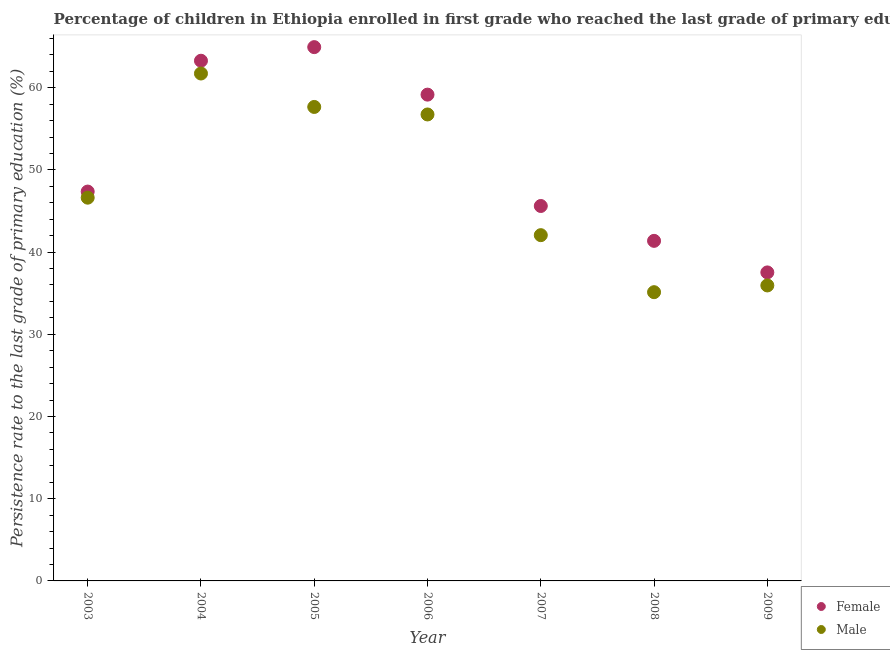What is the persistence rate of male students in 2008?
Offer a terse response. 35.12. Across all years, what is the maximum persistence rate of male students?
Your answer should be compact. 61.72. Across all years, what is the minimum persistence rate of female students?
Ensure brevity in your answer.  37.53. In which year was the persistence rate of male students maximum?
Your answer should be compact. 2004. What is the total persistence rate of female students in the graph?
Provide a succinct answer. 359.24. What is the difference between the persistence rate of female students in 2003 and that in 2006?
Provide a succinct answer. -11.79. What is the difference between the persistence rate of female students in 2006 and the persistence rate of male students in 2004?
Ensure brevity in your answer.  -2.57. What is the average persistence rate of female students per year?
Make the answer very short. 51.32. In the year 2009, what is the difference between the persistence rate of female students and persistence rate of male students?
Give a very brief answer. 1.59. In how many years, is the persistence rate of male students greater than 46 %?
Your answer should be very brief. 4. What is the ratio of the persistence rate of male students in 2005 to that in 2007?
Give a very brief answer. 1.37. Is the difference between the persistence rate of female students in 2005 and 2006 greater than the difference between the persistence rate of male students in 2005 and 2006?
Keep it short and to the point. Yes. What is the difference between the highest and the second highest persistence rate of male students?
Provide a short and direct response. 4.07. What is the difference between the highest and the lowest persistence rate of male students?
Make the answer very short. 26.6. Is the sum of the persistence rate of female students in 2005 and 2006 greater than the maximum persistence rate of male students across all years?
Your answer should be compact. Yes. Is the persistence rate of female students strictly greater than the persistence rate of male students over the years?
Your answer should be very brief. Yes. Are the values on the major ticks of Y-axis written in scientific E-notation?
Keep it short and to the point. No. Does the graph contain any zero values?
Provide a short and direct response. No. Where does the legend appear in the graph?
Your answer should be compact. Bottom right. How many legend labels are there?
Your response must be concise. 2. How are the legend labels stacked?
Provide a short and direct response. Vertical. What is the title of the graph?
Keep it short and to the point. Percentage of children in Ethiopia enrolled in first grade who reached the last grade of primary education. Does "Food and tobacco" appear as one of the legend labels in the graph?
Keep it short and to the point. No. What is the label or title of the X-axis?
Make the answer very short. Year. What is the label or title of the Y-axis?
Ensure brevity in your answer.  Persistence rate to the last grade of primary education (%). What is the Persistence rate to the last grade of primary education (%) of Female in 2003?
Provide a succinct answer. 47.36. What is the Persistence rate to the last grade of primary education (%) of Male in 2003?
Provide a short and direct response. 46.62. What is the Persistence rate to the last grade of primary education (%) of Female in 2004?
Make the answer very short. 63.28. What is the Persistence rate to the last grade of primary education (%) of Male in 2004?
Keep it short and to the point. 61.72. What is the Persistence rate to the last grade of primary education (%) in Female in 2005?
Give a very brief answer. 64.93. What is the Persistence rate to the last grade of primary education (%) of Male in 2005?
Your response must be concise. 57.66. What is the Persistence rate to the last grade of primary education (%) of Female in 2006?
Keep it short and to the point. 59.16. What is the Persistence rate to the last grade of primary education (%) of Male in 2006?
Your response must be concise. 56.74. What is the Persistence rate to the last grade of primary education (%) in Female in 2007?
Offer a very short reply. 45.61. What is the Persistence rate to the last grade of primary education (%) in Male in 2007?
Your answer should be compact. 42.06. What is the Persistence rate to the last grade of primary education (%) in Female in 2008?
Keep it short and to the point. 41.37. What is the Persistence rate to the last grade of primary education (%) of Male in 2008?
Make the answer very short. 35.12. What is the Persistence rate to the last grade of primary education (%) in Female in 2009?
Offer a very short reply. 37.53. What is the Persistence rate to the last grade of primary education (%) of Male in 2009?
Ensure brevity in your answer.  35.94. Across all years, what is the maximum Persistence rate to the last grade of primary education (%) of Female?
Provide a succinct answer. 64.93. Across all years, what is the maximum Persistence rate to the last grade of primary education (%) of Male?
Provide a succinct answer. 61.72. Across all years, what is the minimum Persistence rate to the last grade of primary education (%) in Female?
Your answer should be compact. 37.53. Across all years, what is the minimum Persistence rate to the last grade of primary education (%) in Male?
Ensure brevity in your answer.  35.12. What is the total Persistence rate to the last grade of primary education (%) of Female in the graph?
Your response must be concise. 359.24. What is the total Persistence rate to the last grade of primary education (%) of Male in the graph?
Ensure brevity in your answer.  335.88. What is the difference between the Persistence rate to the last grade of primary education (%) of Female in 2003 and that in 2004?
Your response must be concise. -15.91. What is the difference between the Persistence rate to the last grade of primary education (%) in Male in 2003 and that in 2004?
Your answer should be compact. -15.1. What is the difference between the Persistence rate to the last grade of primary education (%) in Female in 2003 and that in 2005?
Your answer should be compact. -17.57. What is the difference between the Persistence rate to the last grade of primary education (%) of Male in 2003 and that in 2005?
Your answer should be compact. -11.04. What is the difference between the Persistence rate to the last grade of primary education (%) of Female in 2003 and that in 2006?
Keep it short and to the point. -11.79. What is the difference between the Persistence rate to the last grade of primary education (%) in Male in 2003 and that in 2006?
Offer a very short reply. -10.12. What is the difference between the Persistence rate to the last grade of primary education (%) in Female in 2003 and that in 2007?
Your answer should be compact. 1.76. What is the difference between the Persistence rate to the last grade of primary education (%) of Male in 2003 and that in 2007?
Provide a short and direct response. 4.56. What is the difference between the Persistence rate to the last grade of primary education (%) in Female in 2003 and that in 2008?
Ensure brevity in your answer.  6. What is the difference between the Persistence rate to the last grade of primary education (%) of Male in 2003 and that in 2008?
Your response must be concise. 11.5. What is the difference between the Persistence rate to the last grade of primary education (%) of Female in 2003 and that in 2009?
Provide a short and direct response. 9.84. What is the difference between the Persistence rate to the last grade of primary education (%) in Male in 2003 and that in 2009?
Your answer should be compact. 10.68. What is the difference between the Persistence rate to the last grade of primary education (%) in Female in 2004 and that in 2005?
Your response must be concise. -1.66. What is the difference between the Persistence rate to the last grade of primary education (%) of Male in 2004 and that in 2005?
Your answer should be very brief. 4.07. What is the difference between the Persistence rate to the last grade of primary education (%) of Female in 2004 and that in 2006?
Provide a short and direct response. 4.12. What is the difference between the Persistence rate to the last grade of primary education (%) of Male in 2004 and that in 2006?
Make the answer very short. 4.98. What is the difference between the Persistence rate to the last grade of primary education (%) in Female in 2004 and that in 2007?
Your response must be concise. 17.67. What is the difference between the Persistence rate to the last grade of primary education (%) in Male in 2004 and that in 2007?
Offer a very short reply. 19.66. What is the difference between the Persistence rate to the last grade of primary education (%) of Female in 2004 and that in 2008?
Your answer should be compact. 21.91. What is the difference between the Persistence rate to the last grade of primary education (%) in Male in 2004 and that in 2008?
Offer a terse response. 26.6. What is the difference between the Persistence rate to the last grade of primary education (%) of Female in 2004 and that in 2009?
Ensure brevity in your answer.  25.75. What is the difference between the Persistence rate to the last grade of primary education (%) of Male in 2004 and that in 2009?
Provide a short and direct response. 25.78. What is the difference between the Persistence rate to the last grade of primary education (%) in Female in 2005 and that in 2006?
Give a very brief answer. 5.78. What is the difference between the Persistence rate to the last grade of primary education (%) of Male in 2005 and that in 2006?
Ensure brevity in your answer.  0.91. What is the difference between the Persistence rate to the last grade of primary education (%) of Female in 2005 and that in 2007?
Your answer should be compact. 19.33. What is the difference between the Persistence rate to the last grade of primary education (%) in Male in 2005 and that in 2007?
Provide a short and direct response. 15.6. What is the difference between the Persistence rate to the last grade of primary education (%) in Female in 2005 and that in 2008?
Your answer should be compact. 23.57. What is the difference between the Persistence rate to the last grade of primary education (%) in Male in 2005 and that in 2008?
Provide a succinct answer. 22.53. What is the difference between the Persistence rate to the last grade of primary education (%) in Female in 2005 and that in 2009?
Offer a terse response. 27.41. What is the difference between the Persistence rate to the last grade of primary education (%) of Male in 2005 and that in 2009?
Provide a succinct answer. 21.71. What is the difference between the Persistence rate to the last grade of primary education (%) in Female in 2006 and that in 2007?
Give a very brief answer. 13.55. What is the difference between the Persistence rate to the last grade of primary education (%) of Male in 2006 and that in 2007?
Make the answer very short. 14.68. What is the difference between the Persistence rate to the last grade of primary education (%) of Female in 2006 and that in 2008?
Ensure brevity in your answer.  17.79. What is the difference between the Persistence rate to the last grade of primary education (%) of Male in 2006 and that in 2008?
Provide a succinct answer. 21.62. What is the difference between the Persistence rate to the last grade of primary education (%) of Female in 2006 and that in 2009?
Make the answer very short. 21.63. What is the difference between the Persistence rate to the last grade of primary education (%) in Male in 2006 and that in 2009?
Your answer should be compact. 20.8. What is the difference between the Persistence rate to the last grade of primary education (%) in Female in 2007 and that in 2008?
Give a very brief answer. 4.24. What is the difference between the Persistence rate to the last grade of primary education (%) of Male in 2007 and that in 2008?
Offer a terse response. 6.94. What is the difference between the Persistence rate to the last grade of primary education (%) in Female in 2007 and that in 2009?
Your response must be concise. 8.08. What is the difference between the Persistence rate to the last grade of primary education (%) of Male in 2007 and that in 2009?
Make the answer very short. 6.12. What is the difference between the Persistence rate to the last grade of primary education (%) of Female in 2008 and that in 2009?
Offer a terse response. 3.84. What is the difference between the Persistence rate to the last grade of primary education (%) in Male in 2008 and that in 2009?
Your answer should be very brief. -0.82. What is the difference between the Persistence rate to the last grade of primary education (%) of Female in 2003 and the Persistence rate to the last grade of primary education (%) of Male in 2004?
Ensure brevity in your answer.  -14.36. What is the difference between the Persistence rate to the last grade of primary education (%) in Female in 2003 and the Persistence rate to the last grade of primary education (%) in Male in 2005?
Your answer should be very brief. -10.29. What is the difference between the Persistence rate to the last grade of primary education (%) in Female in 2003 and the Persistence rate to the last grade of primary education (%) in Male in 2006?
Provide a short and direct response. -9.38. What is the difference between the Persistence rate to the last grade of primary education (%) of Female in 2003 and the Persistence rate to the last grade of primary education (%) of Male in 2007?
Your answer should be very brief. 5.3. What is the difference between the Persistence rate to the last grade of primary education (%) of Female in 2003 and the Persistence rate to the last grade of primary education (%) of Male in 2008?
Provide a short and direct response. 12.24. What is the difference between the Persistence rate to the last grade of primary education (%) of Female in 2003 and the Persistence rate to the last grade of primary education (%) of Male in 2009?
Provide a succinct answer. 11.42. What is the difference between the Persistence rate to the last grade of primary education (%) of Female in 2004 and the Persistence rate to the last grade of primary education (%) of Male in 2005?
Give a very brief answer. 5.62. What is the difference between the Persistence rate to the last grade of primary education (%) in Female in 2004 and the Persistence rate to the last grade of primary education (%) in Male in 2006?
Provide a short and direct response. 6.54. What is the difference between the Persistence rate to the last grade of primary education (%) in Female in 2004 and the Persistence rate to the last grade of primary education (%) in Male in 2007?
Offer a terse response. 21.22. What is the difference between the Persistence rate to the last grade of primary education (%) in Female in 2004 and the Persistence rate to the last grade of primary education (%) in Male in 2008?
Make the answer very short. 28.15. What is the difference between the Persistence rate to the last grade of primary education (%) in Female in 2004 and the Persistence rate to the last grade of primary education (%) in Male in 2009?
Provide a succinct answer. 27.34. What is the difference between the Persistence rate to the last grade of primary education (%) in Female in 2005 and the Persistence rate to the last grade of primary education (%) in Male in 2006?
Your answer should be very brief. 8.19. What is the difference between the Persistence rate to the last grade of primary education (%) of Female in 2005 and the Persistence rate to the last grade of primary education (%) of Male in 2007?
Your answer should be very brief. 22.87. What is the difference between the Persistence rate to the last grade of primary education (%) in Female in 2005 and the Persistence rate to the last grade of primary education (%) in Male in 2008?
Your response must be concise. 29.81. What is the difference between the Persistence rate to the last grade of primary education (%) of Female in 2005 and the Persistence rate to the last grade of primary education (%) of Male in 2009?
Your answer should be compact. 28.99. What is the difference between the Persistence rate to the last grade of primary education (%) in Female in 2006 and the Persistence rate to the last grade of primary education (%) in Male in 2007?
Give a very brief answer. 17.1. What is the difference between the Persistence rate to the last grade of primary education (%) in Female in 2006 and the Persistence rate to the last grade of primary education (%) in Male in 2008?
Provide a short and direct response. 24.03. What is the difference between the Persistence rate to the last grade of primary education (%) of Female in 2006 and the Persistence rate to the last grade of primary education (%) of Male in 2009?
Offer a terse response. 23.21. What is the difference between the Persistence rate to the last grade of primary education (%) in Female in 2007 and the Persistence rate to the last grade of primary education (%) in Male in 2008?
Your answer should be very brief. 10.48. What is the difference between the Persistence rate to the last grade of primary education (%) of Female in 2007 and the Persistence rate to the last grade of primary education (%) of Male in 2009?
Your answer should be very brief. 9.67. What is the difference between the Persistence rate to the last grade of primary education (%) of Female in 2008 and the Persistence rate to the last grade of primary education (%) of Male in 2009?
Offer a terse response. 5.42. What is the average Persistence rate to the last grade of primary education (%) in Female per year?
Make the answer very short. 51.32. What is the average Persistence rate to the last grade of primary education (%) in Male per year?
Your answer should be very brief. 47.98. In the year 2003, what is the difference between the Persistence rate to the last grade of primary education (%) in Female and Persistence rate to the last grade of primary education (%) in Male?
Your response must be concise. 0.74. In the year 2004, what is the difference between the Persistence rate to the last grade of primary education (%) of Female and Persistence rate to the last grade of primary education (%) of Male?
Offer a terse response. 1.55. In the year 2005, what is the difference between the Persistence rate to the last grade of primary education (%) of Female and Persistence rate to the last grade of primary education (%) of Male?
Ensure brevity in your answer.  7.28. In the year 2006, what is the difference between the Persistence rate to the last grade of primary education (%) of Female and Persistence rate to the last grade of primary education (%) of Male?
Offer a terse response. 2.41. In the year 2007, what is the difference between the Persistence rate to the last grade of primary education (%) of Female and Persistence rate to the last grade of primary education (%) of Male?
Provide a short and direct response. 3.55. In the year 2008, what is the difference between the Persistence rate to the last grade of primary education (%) of Female and Persistence rate to the last grade of primary education (%) of Male?
Give a very brief answer. 6.24. In the year 2009, what is the difference between the Persistence rate to the last grade of primary education (%) in Female and Persistence rate to the last grade of primary education (%) in Male?
Your response must be concise. 1.59. What is the ratio of the Persistence rate to the last grade of primary education (%) in Female in 2003 to that in 2004?
Provide a succinct answer. 0.75. What is the ratio of the Persistence rate to the last grade of primary education (%) of Male in 2003 to that in 2004?
Your answer should be compact. 0.76. What is the ratio of the Persistence rate to the last grade of primary education (%) of Female in 2003 to that in 2005?
Make the answer very short. 0.73. What is the ratio of the Persistence rate to the last grade of primary education (%) in Male in 2003 to that in 2005?
Make the answer very short. 0.81. What is the ratio of the Persistence rate to the last grade of primary education (%) in Female in 2003 to that in 2006?
Give a very brief answer. 0.8. What is the ratio of the Persistence rate to the last grade of primary education (%) of Male in 2003 to that in 2006?
Your response must be concise. 0.82. What is the ratio of the Persistence rate to the last grade of primary education (%) of Female in 2003 to that in 2007?
Your answer should be compact. 1.04. What is the ratio of the Persistence rate to the last grade of primary education (%) of Male in 2003 to that in 2007?
Ensure brevity in your answer.  1.11. What is the ratio of the Persistence rate to the last grade of primary education (%) in Female in 2003 to that in 2008?
Make the answer very short. 1.14. What is the ratio of the Persistence rate to the last grade of primary education (%) of Male in 2003 to that in 2008?
Ensure brevity in your answer.  1.33. What is the ratio of the Persistence rate to the last grade of primary education (%) in Female in 2003 to that in 2009?
Offer a terse response. 1.26. What is the ratio of the Persistence rate to the last grade of primary education (%) of Male in 2003 to that in 2009?
Make the answer very short. 1.3. What is the ratio of the Persistence rate to the last grade of primary education (%) of Female in 2004 to that in 2005?
Make the answer very short. 0.97. What is the ratio of the Persistence rate to the last grade of primary education (%) of Male in 2004 to that in 2005?
Offer a very short reply. 1.07. What is the ratio of the Persistence rate to the last grade of primary education (%) of Female in 2004 to that in 2006?
Give a very brief answer. 1.07. What is the ratio of the Persistence rate to the last grade of primary education (%) in Male in 2004 to that in 2006?
Your answer should be very brief. 1.09. What is the ratio of the Persistence rate to the last grade of primary education (%) of Female in 2004 to that in 2007?
Make the answer very short. 1.39. What is the ratio of the Persistence rate to the last grade of primary education (%) in Male in 2004 to that in 2007?
Offer a terse response. 1.47. What is the ratio of the Persistence rate to the last grade of primary education (%) in Female in 2004 to that in 2008?
Your answer should be compact. 1.53. What is the ratio of the Persistence rate to the last grade of primary education (%) of Male in 2004 to that in 2008?
Make the answer very short. 1.76. What is the ratio of the Persistence rate to the last grade of primary education (%) of Female in 2004 to that in 2009?
Your response must be concise. 1.69. What is the ratio of the Persistence rate to the last grade of primary education (%) of Male in 2004 to that in 2009?
Offer a very short reply. 1.72. What is the ratio of the Persistence rate to the last grade of primary education (%) of Female in 2005 to that in 2006?
Offer a very short reply. 1.1. What is the ratio of the Persistence rate to the last grade of primary education (%) in Male in 2005 to that in 2006?
Your answer should be compact. 1.02. What is the ratio of the Persistence rate to the last grade of primary education (%) of Female in 2005 to that in 2007?
Your answer should be very brief. 1.42. What is the ratio of the Persistence rate to the last grade of primary education (%) of Male in 2005 to that in 2007?
Your answer should be very brief. 1.37. What is the ratio of the Persistence rate to the last grade of primary education (%) in Female in 2005 to that in 2008?
Ensure brevity in your answer.  1.57. What is the ratio of the Persistence rate to the last grade of primary education (%) in Male in 2005 to that in 2008?
Your answer should be compact. 1.64. What is the ratio of the Persistence rate to the last grade of primary education (%) of Female in 2005 to that in 2009?
Make the answer very short. 1.73. What is the ratio of the Persistence rate to the last grade of primary education (%) of Male in 2005 to that in 2009?
Provide a short and direct response. 1.6. What is the ratio of the Persistence rate to the last grade of primary education (%) of Female in 2006 to that in 2007?
Make the answer very short. 1.3. What is the ratio of the Persistence rate to the last grade of primary education (%) in Male in 2006 to that in 2007?
Your answer should be very brief. 1.35. What is the ratio of the Persistence rate to the last grade of primary education (%) in Female in 2006 to that in 2008?
Ensure brevity in your answer.  1.43. What is the ratio of the Persistence rate to the last grade of primary education (%) in Male in 2006 to that in 2008?
Give a very brief answer. 1.62. What is the ratio of the Persistence rate to the last grade of primary education (%) of Female in 2006 to that in 2009?
Your response must be concise. 1.58. What is the ratio of the Persistence rate to the last grade of primary education (%) of Male in 2006 to that in 2009?
Make the answer very short. 1.58. What is the ratio of the Persistence rate to the last grade of primary education (%) in Female in 2007 to that in 2008?
Your answer should be very brief. 1.1. What is the ratio of the Persistence rate to the last grade of primary education (%) of Male in 2007 to that in 2008?
Your answer should be very brief. 1.2. What is the ratio of the Persistence rate to the last grade of primary education (%) of Female in 2007 to that in 2009?
Offer a terse response. 1.22. What is the ratio of the Persistence rate to the last grade of primary education (%) of Male in 2007 to that in 2009?
Your response must be concise. 1.17. What is the ratio of the Persistence rate to the last grade of primary education (%) in Female in 2008 to that in 2009?
Make the answer very short. 1.1. What is the ratio of the Persistence rate to the last grade of primary education (%) of Male in 2008 to that in 2009?
Provide a succinct answer. 0.98. What is the difference between the highest and the second highest Persistence rate to the last grade of primary education (%) of Female?
Make the answer very short. 1.66. What is the difference between the highest and the second highest Persistence rate to the last grade of primary education (%) of Male?
Give a very brief answer. 4.07. What is the difference between the highest and the lowest Persistence rate to the last grade of primary education (%) in Female?
Give a very brief answer. 27.41. What is the difference between the highest and the lowest Persistence rate to the last grade of primary education (%) of Male?
Your response must be concise. 26.6. 